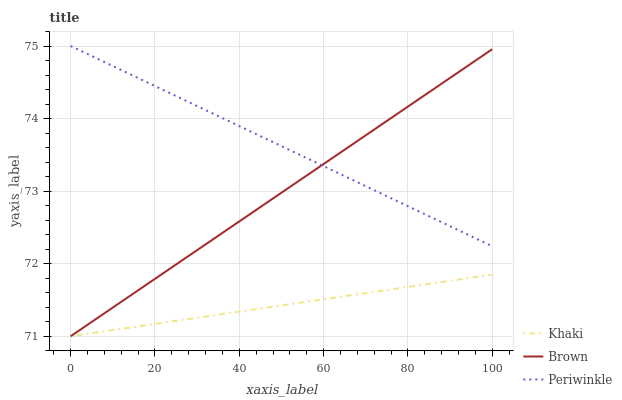Does Khaki have the minimum area under the curve?
Answer yes or no. Yes. Does Periwinkle have the maximum area under the curve?
Answer yes or no. Yes. Does Periwinkle have the minimum area under the curve?
Answer yes or no. No. Does Khaki have the maximum area under the curve?
Answer yes or no. No. Is Periwinkle the smoothest?
Answer yes or no. Yes. Is Brown the roughest?
Answer yes or no. Yes. Is Khaki the smoothest?
Answer yes or no. No. Is Khaki the roughest?
Answer yes or no. No. Does Brown have the lowest value?
Answer yes or no. Yes. Does Periwinkle have the lowest value?
Answer yes or no. No. Does Periwinkle have the highest value?
Answer yes or no. Yes. Does Khaki have the highest value?
Answer yes or no. No. Is Khaki less than Periwinkle?
Answer yes or no. Yes. Is Periwinkle greater than Khaki?
Answer yes or no. Yes. Does Khaki intersect Brown?
Answer yes or no. Yes. Is Khaki less than Brown?
Answer yes or no. No. Is Khaki greater than Brown?
Answer yes or no. No. Does Khaki intersect Periwinkle?
Answer yes or no. No. 